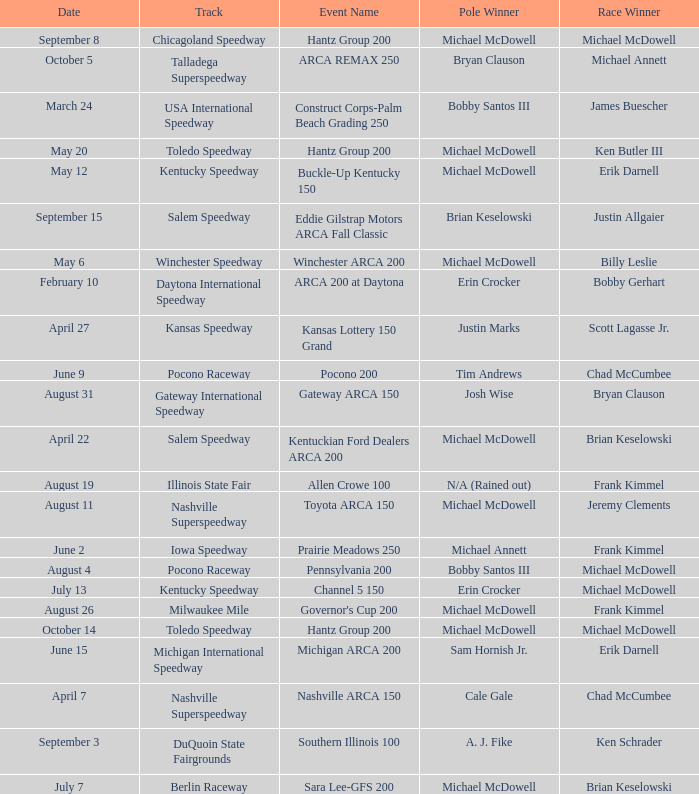Tell me the pole winner of may 12 Michael McDowell. 